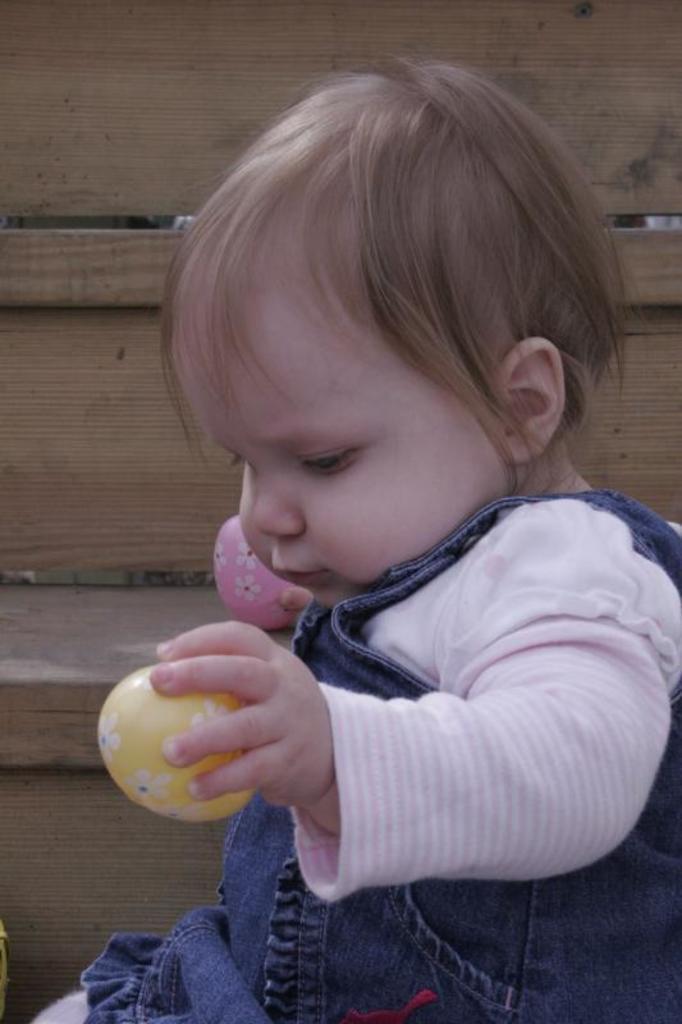Could you give a brief overview of what you see in this image? In this image there is a wooden staircase, there is a kid holding objectś. 